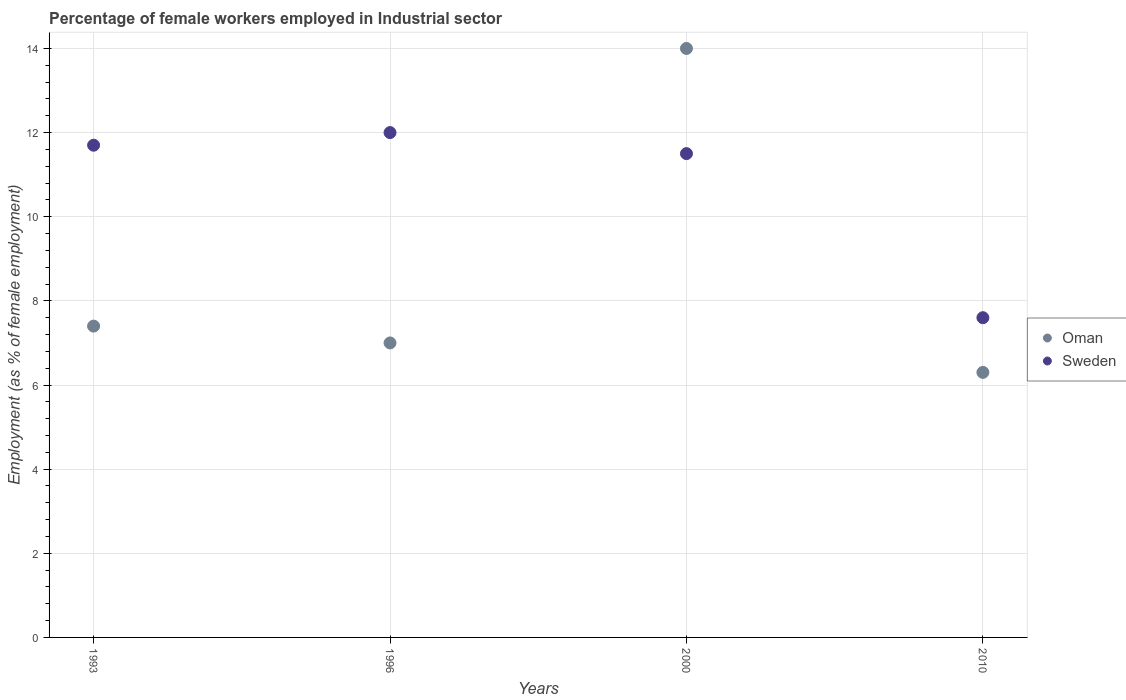Is the number of dotlines equal to the number of legend labels?
Make the answer very short. Yes. Across all years, what is the minimum percentage of females employed in Industrial sector in Oman?
Your answer should be very brief. 6.3. In which year was the percentage of females employed in Industrial sector in Oman minimum?
Keep it short and to the point. 2010. What is the total percentage of females employed in Industrial sector in Oman in the graph?
Offer a very short reply. 34.7. What is the difference between the percentage of females employed in Industrial sector in Sweden in 2000 and that in 2010?
Provide a short and direct response. 3.9. What is the difference between the percentage of females employed in Industrial sector in Oman in 2000 and the percentage of females employed in Industrial sector in Sweden in 2010?
Keep it short and to the point. 6.4. What is the average percentage of females employed in Industrial sector in Oman per year?
Provide a succinct answer. 8.68. In the year 2010, what is the difference between the percentage of females employed in Industrial sector in Sweden and percentage of females employed in Industrial sector in Oman?
Your answer should be very brief. 1.3. In how many years, is the percentage of females employed in Industrial sector in Oman greater than 13.2 %?
Your answer should be compact. 1. What is the ratio of the percentage of females employed in Industrial sector in Sweden in 1993 to that in 2010?
Your response must be concise. 1.54. Is the percentage of females employed in Industrial sector in Sweden in 1993 less than that in 1996?
Offer a very short reply. Yes. Is the difference between the percentage of females employed in Industrial sector in Sweden in 1993 and 2000 greater than the difference between the percentage of females employed in Industrial sector in Oman in 1993 and 2000?
Provide a short and direct response. Yes. What is the difference between the highest and the second highest percentage of females employed in Industrial sector in Sweden?
Make the answer very short. 0.3. What is the difference between the highest and the lowest percentage of females employed in Industrial sector in Sweden?
Offer a terse response. 4.4. In how many years, is the percentage of females employed in Industrial sector in Oman greater than the average percentage of females employed in Industrial sector in Oman taken over all years?
Provide a short and direct response. 1. Does the percentage of females employed in Industrial sector in Sweden monotonically increase over the years?
Your answer should be very brief. No. Is the percentage of females employed in Industrial sector in Sweden strictly greater than the percentage of females employed in Industrial sector in Oman over the years?
Ensure brevity in your answer.  No. Is the percentage of females employed in Industrial sector in Oman strictly less than the percentage of females employed in Industrial sector in Sweden over the years?
Your answer should be compact. No. How many years are there in the graph?
Provide a succinct answer. 4. Are the values on the major ticks of Y-axis written in scientific E-notation?
Give a very brief answer. No. What is the title of the graph?
Your response must be concise. Percentage of female workers employed in Industrial sector. What is the label or title of the Y-axis?
Make the answer very short. Employment (as % of female employment). What is the Employment (as % of female employment) in Oman in 1993?
Provide a short and direct response. 7.4. What is the Employment (as % of female employment) in Sweden in 1993?
Your response must be concise. 11.7. What is the Employment (as % of female employment) in Oman in 2000?
Keep it short and to the point. 14. What is the Employment (as % of female employment) in Oman in 2010?
Give a very brief answer. 6.3. What is the Employment (as % of female employment) of Sweden in 2010?
Offer a very short reply. 7.6. Across all years, what is the minimum Employment (as % of female employment) of Oman?
Offer a terse response. 6.3. Across all years, what is the minimum Employment (as % of female employment) of Sweden?
Keep it short and to the point. 7.6. What is the total Employment (as % of female employment) of Oman in the graph?
Offer a very short reply. 34.7. What is the total Employment (as % of female employment) in Sweden in the graph?
Your answer should be compact. 42.8. What is the difference between the Employment (as % of female employment) of Oman in 1993 and that in 1996?
Make the answer very short. 0.4. What is the difference between the Employment (as % of female employment) of Oman in 1993 and that in 2000?
Ensure brevity in your answer.  -6.6. What is the difference between the Employment (as % of female employment) in Sweden in 1993 and that in 2010?
Keep it short and to the point. 4.1. What is the difference between the Employment (as % of female employment) in Sweden in 1996 and that in 2000?
Ensure brevity in your answer.  0.5. What is the difference between the Employment (as % of female employment) of Oman in 1996 and that in 2010?
Give a very brief answer. 0.7. What is the difference between the Employment (as % of female employment) in Oman in 2000 and that in 2010?
Offer a very short reply. 7.7. What is the difference between the Employment (as % of female employment) of Oman in 1993 and the Employment (as % of female employment) of Sweden in 2000?
Keep it short and to the point. -4.1. What is the difference between the Employment (as % of female employment) in Oman in 1993 and the Employment (as % of female employment) in Sweden in 2010?
Your answer should be compact. -0.2. What is the difference between the Employment (as % of female employment) in Oman in 1996 and the Employment (as % of female employment) in Sweden in 2000?
Your answer should be compact. -4.5. What is the average Employment (as % of female employment) in Oman per year?
Keep it short and to the point. 8.68. In the year 1996, what is the difference between the Employment (as % of female employment) in Oman and Employment (as % of female employment) in Sweden?
Give a very brief answer. -5. In the year 2000, what is the difference between the Employment (as % of female employment) in Oman and Employment (as % of female employment) in Sweden?
Make the answer very short. 2.5. What is the ratio of the Employment (as % of female employment) in Oman in 1993 to that in 1996?
Give a very brief answer. 1.06. What is the ratio of the Employment (as % of female employment) of Oman in 1993 to that in 2000?
Your answer should be very brief. 0.53. What is the ratio of the Employment (as % of female employment) of Sweden in 1993 to that in 2000?
Offer a very short reply. 1.02. What is the ratio of the Employment (as % of female employment) in Oman in 1993 to that in 2010?
Your answer should be compact. 1.17. What is the ratio of the Employment (as % of female employment) of Sweden in 1993 to that in 2010?
Provide a short and direct response. 1.54. What is the ratio of the Employment (as % of female employment) of Sweden in 1996 to that in 2000?
Your answer should be very brief. 1.04. What is the ratio of the Employment (as % of female employment) in Oman in 1996 to that in 2010?
Your answer should be very brief. 1.11. What is the ratio of the Employment (as % of female employment) in Sweden in 1996 to that in 2010?
Provide a succinct answer. 1.58. What is the ratio of the Employment (as % of female employment) in Oman in 2000 to that in 2010?
Offer a very short reply. 2.22. What is the ratio of the Employment (as % of female employment) in Sweden in 2000 to that in 2010?
Make the answer very short. 1.51. What is the difference between the highest and the second highest Employment (as % of female employment) of Oman?
Offer a very short reply. 6.6. What is the difference between the highest and the lowest Employment (as % of female employment) in Oman?
Provide a succinct answer. 7.7. What is the difference between the highest and the lowest Employment (as % of female employment) of Sweden?
Provide a short and direct response. 4.4. 